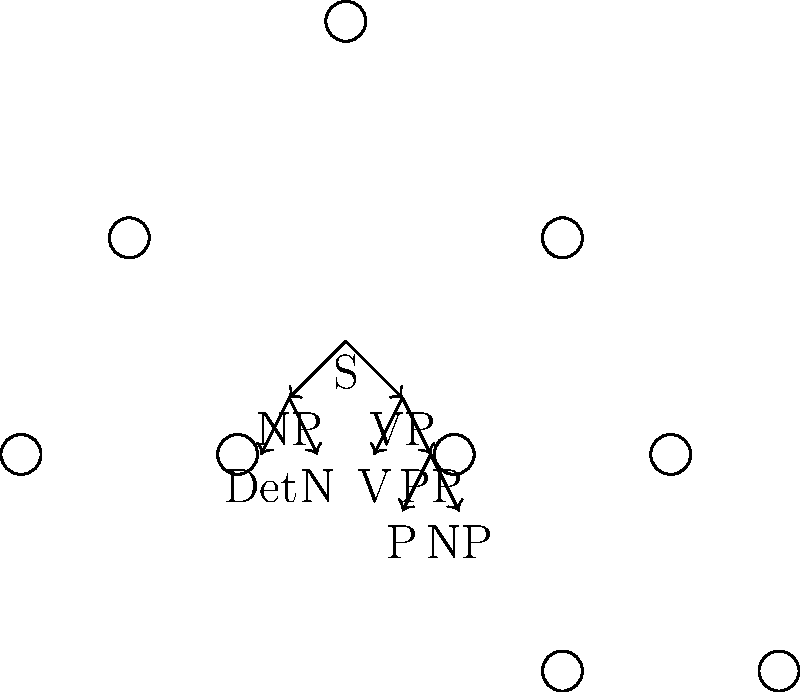In the parse tree representation of the sentence "The linguist analyzed data with algorithms", which constituent directly dominates the prepositional phrase (PP)? To answer this question, let's analyze the parse tree step-by-step:

1. The root node of the tree is S (Sentence).

2. S directly dominates two constituents: NP (Noun Phrase) and VP (Verb Phrase).

3. The NP branch likely represents "The linguist":
   - Det (Determiner) for "The"
   - N (Noun) for "linguist"

4. The VP branch contains the rest of the sentence:
   - V (Verb) for "analyzed"
   - The direct object "data" (not explicitly shown in this simplified tree)
   - PP (Prepositional Phrase) for "with algorithms"

5. The PP is further divided into:
   - P (Preposition) for "with"
   - NP (Noun Phrase) for "algorithms"

6. Crucially, we can see that the PP node is directly connected to the VP node above it.

Therefore, the constituent that directly dominates the prepositional phrase (PP) is the VP (Verb Phrase).
Answer: VP (Verb Phrase) 